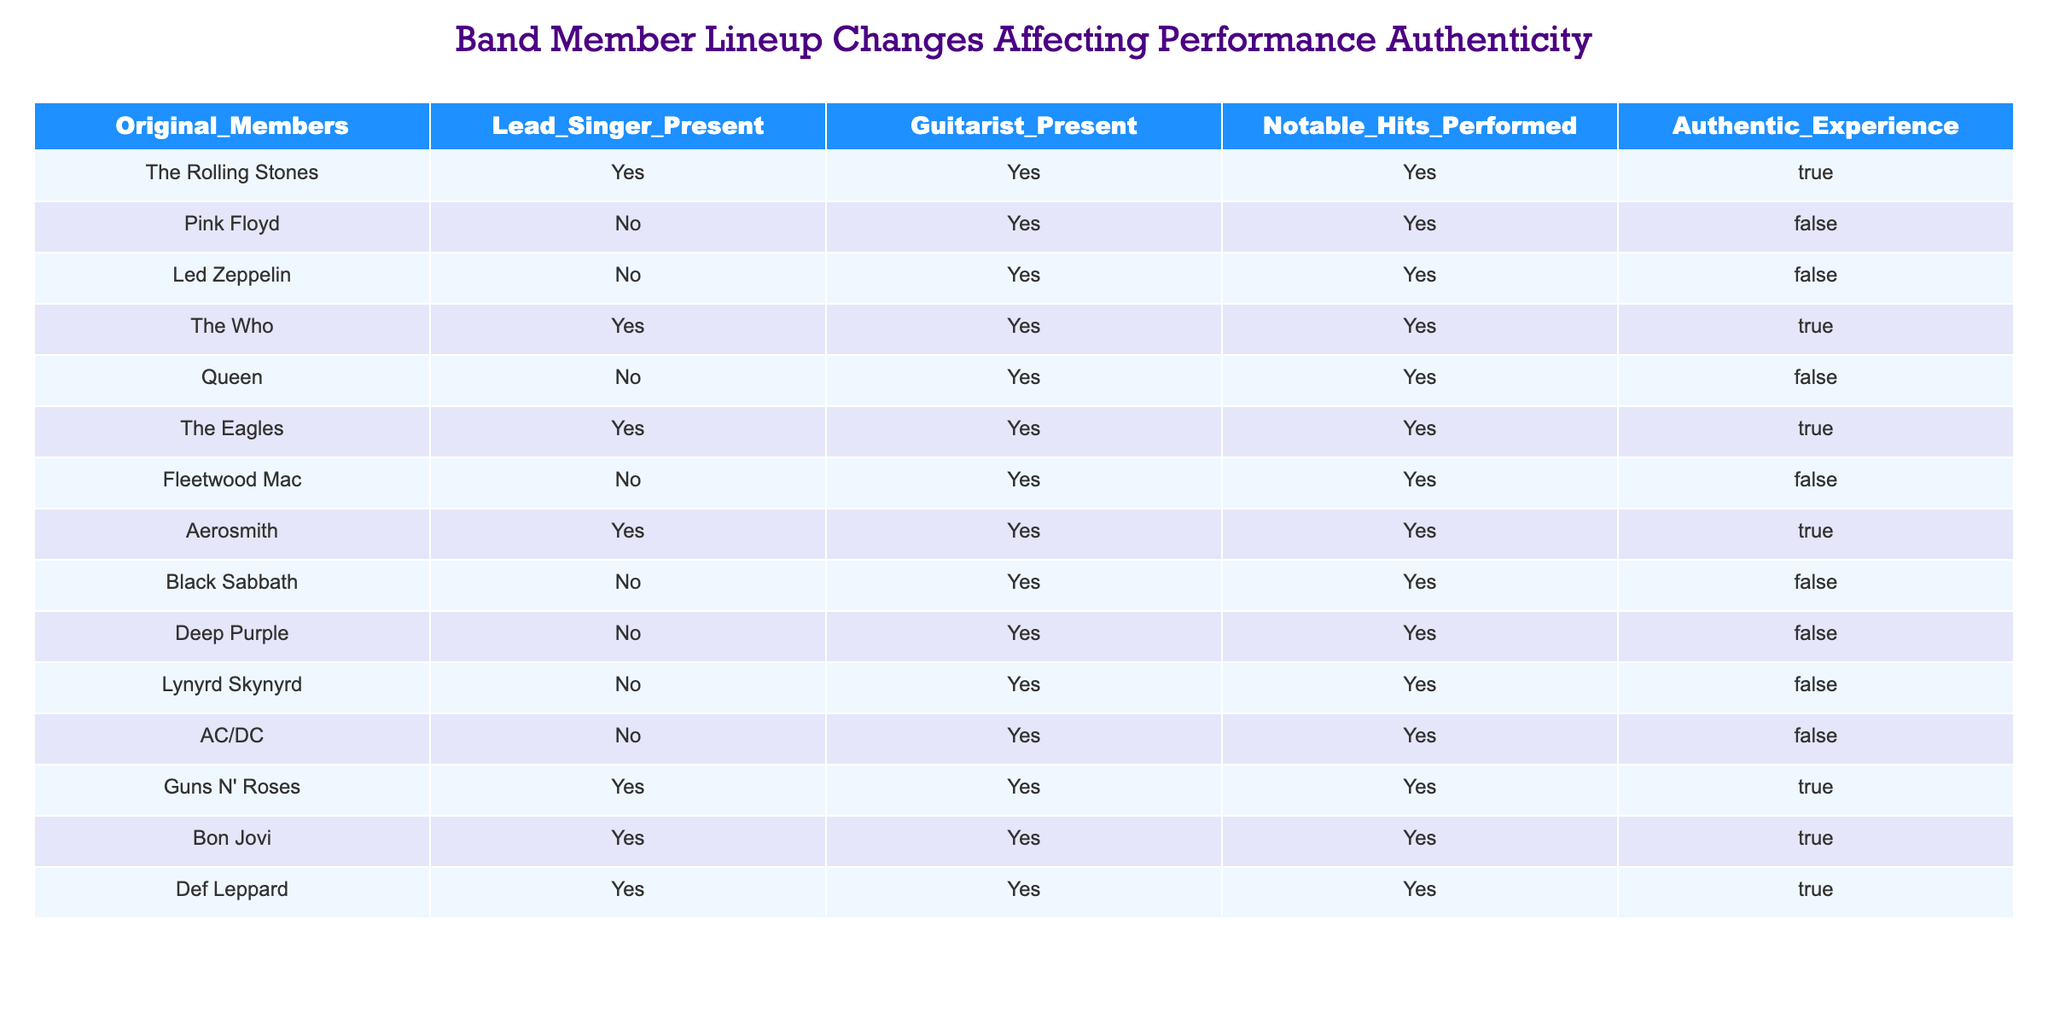What percentage of bands have their original members present? There are 14 bands in total, and 6 of them have their original members present (The Rolling Stones, The Who, The Eagles, Aerosmith, Guns N' Roses, Bon Jovi, and Def Leppard). To find the percentage, we divide the number of bands with original members by the total number of bands: (6/14) * 100 = 42.86%.
Answer: 42.86% How many bands have neither the lead singer nor the original members present and still performed notable hits? From the table, we can identify that bands like Pink Floyd, Led Zeppelin, Queen, Fleetwood Mac, Black Sabbath, Deep Purple, Lynyrd Skynyrd, and AC/DC performed notable hits without original members or lead singers present. This gives us a total of 8 bands.
Answer: 8 Is it true that all bands with an authentic experience have both the lead singer and guitarist present? To answer this question, we check the 'Authentic Experience' column for bands that are marked as 'True'. Looking at those rows, we will check if the lead singer and guitarist are marked as 'Yes' for all. The bands with an authentic experience (The Rolling Stones, The Who, The Eagles, Aerosmith, Guns N' Roses, Bon Jovi, Def Leppard) all have 'Yes' for both lead singer and guitarist. Thus, it is true.
Answer: Yes Which band has the most notable hits performed while lacking both the lead singer and original members? We identify which bands do not have the lead singer and original members and see how many notable hits they have performed. From the table, we see bands like Pink Floyd, Led Zeppelin, Queen, Fleetwood Mac, Black Sabbath, Deep Purple, Lynyrd Skynyrd, and AC/DC. They have performed notable hits, but they are all limited to one, so there is no specific band with more than others.
Answer: N/A (all have 1) Which bands have an authentic experience and also do not perform remarkable hits? The question aims to identify any band fitting both criteria. However, from the table, all bands marked as having an authentic experience perform notable hits. Therefore, there are no such bands.
Answer: None 